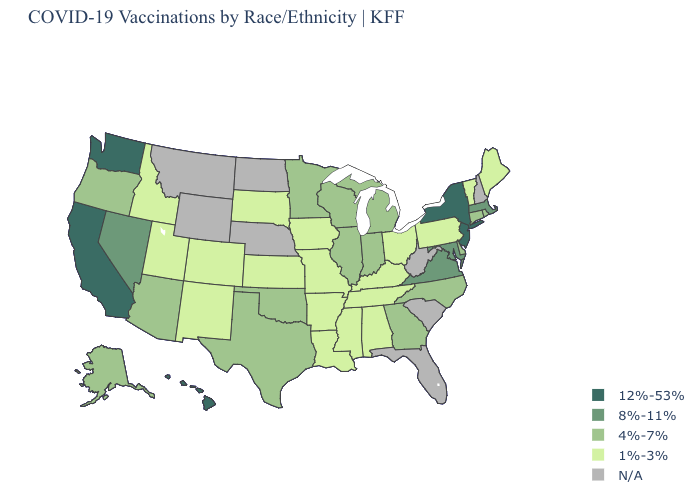Among the states that border Vermont , does Massachusetts have the highest value?
Quick response, please. No. Name the states that have a value in the range 1%-3%?
Write a very short answer. Alabama, Arkansas, Colorado, Idaho, Iowa, Kansas, Kentucky, Louisiana, Maine, Mississippi, Missouri, New Mexico, Ohio, Pennsylvania, South Dakota, Tennessee, Utah, Vermont. Does the first symbol in the legend represent the smallest category?
Write a very short answer. No. Name the states that have a value in the range 4%-7%?
Concise answer only. Alaska, Arizona, Connecticut, Delaware, Georgia, Illinois, Indiana, Michigan, Minnesota, North Carolina, Oklahoma, Oregon, Rhode Island, Texas, Wisconsin. What is the value of Nevada?
Quick response, please. 8%-11%. What is the highest value in states that border North Carolina?
Be succinct. 8%-11%. What is the value of Rhode Island?
Short answer required. 4%-7%. What is the highest value in the MidWest ?
Write a very short answer. 4%-7%. Name the states that have a value in the range 12%-53%?
Keep it brief. California, Hawaii, New Jersey, New York, Washington. Does Georgia have the highest value in the South?
Short answer required. No. What is the highest value in the USA?
Short answer required. 12%-53%. Does Maryland have the highest value in the South?
Give a very brief answer. Yes. Does Virginia have the highest value in the South?
Give a very brief answer. Yes. Which states have the lowest value in the USA?
Give a very brief answer. Alabama, Arkansas, Colorado, Idaho, Iowa, Kansas, Kentucky, Louisiana, Maine, Mississippi, Missouri, New Mexico, Ohio, Pennsylvania, South Dakota, Tennessee, Utah, Vermont. 